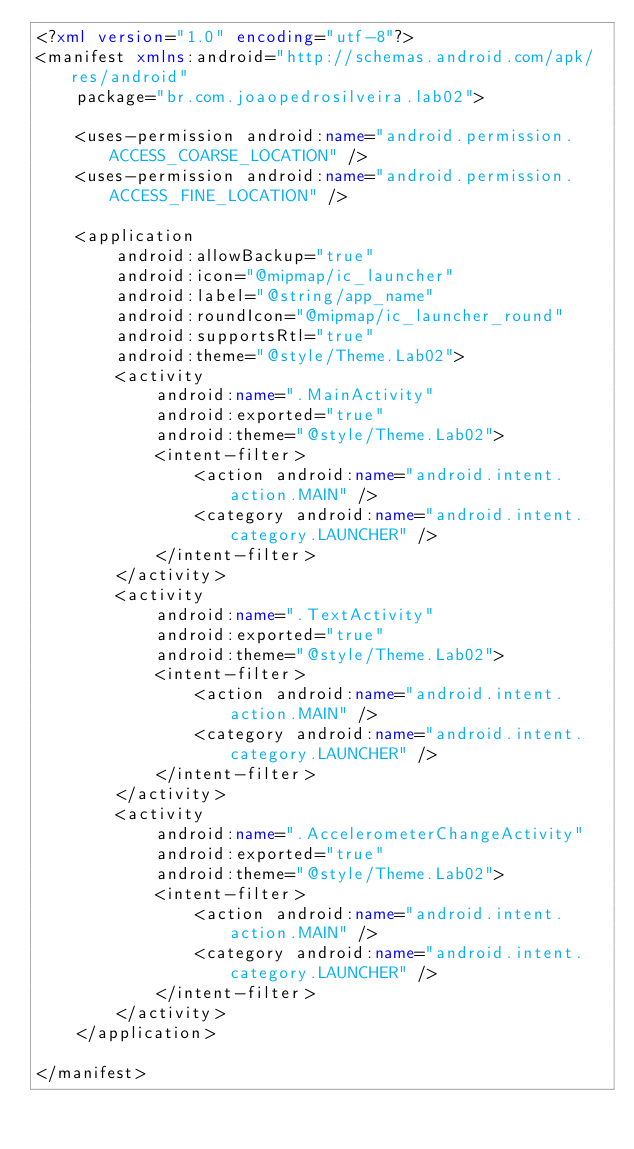<code> <loc_0><loc_0><loc_500><loc_500><_XML_><?xml version="1.0" encoding="utf-8"?>
<manifest xmlns:android="http://schemas.android.com/apk/res/android"
    package="br.com.joaopedrosilveira.lab02">

    <uses-permission android:name="android.permission.ACCESS_COARSE_LOCATION" />
    <uses-permission android:name="android.permission.ACCESS_FINE_LOCATION" />

    <application
        android:allowBackup="true"
        android:icon="@mipmap/ic_launcher"
        android:label="@string/app_name"
        android:roundIcon="@mipmap/ic_launcher_round"
        android:supportsRtl="true"
        android:theme="@style/Theme.Lab02">
        <activity
            android:name=".MainActivity"
            android:exported="true"
            android:theme="@style/Theme.Lab02">
            <intent-filter>
                <action android:name="android.intent.action.MAIN" />
                <category android:name="android.intent.category.LAUNCHER" />
            </intent-filter>
        </activity>
        <activity
            android:name=".TextActivity"
            android:exported="true"
            android:theme="@style/Theme.Lab02">
            <intent-filter>
                <action android:name="android.intent.action.MAIN" />
                <category android:name="android.intent.category.LAUNCHER" />
            </intent-filter>
        </activity>
        <activity
            android:name=".AccelerometerChangeActivity"
            android:exported="true"
            android:theme="@style/Theme.Lab02">
            <intent-filter>
                <action android:name="android.intent.action.MAIN" />
                <category android:name="android.intent.category.LAUNCHER" />
            </intent-filter>
        </activity>
    </application>

</manifest></code> 